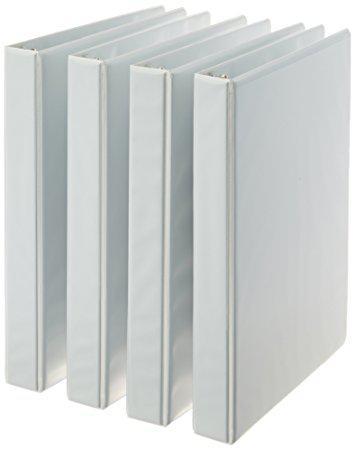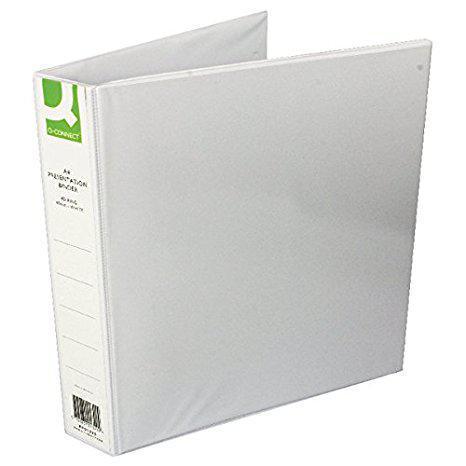The first image is the image on the left, the second image is the image on the right. Evaluate the accuracy of this statement regarding the images: "All binders shown are white and all binders are displayed upright.". Is it true? Answer yes or no. Yes. The first image is the image on the left, the second image is the image on the right. Examine the images to the left and right. Is the description "All binders are the base color white and there are at least five present." accurate? Answer yes or no. Yes. 